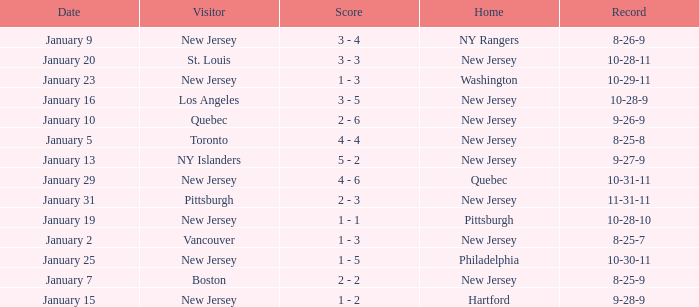What was the date that ended in a record of 8-25-7? January 2. 